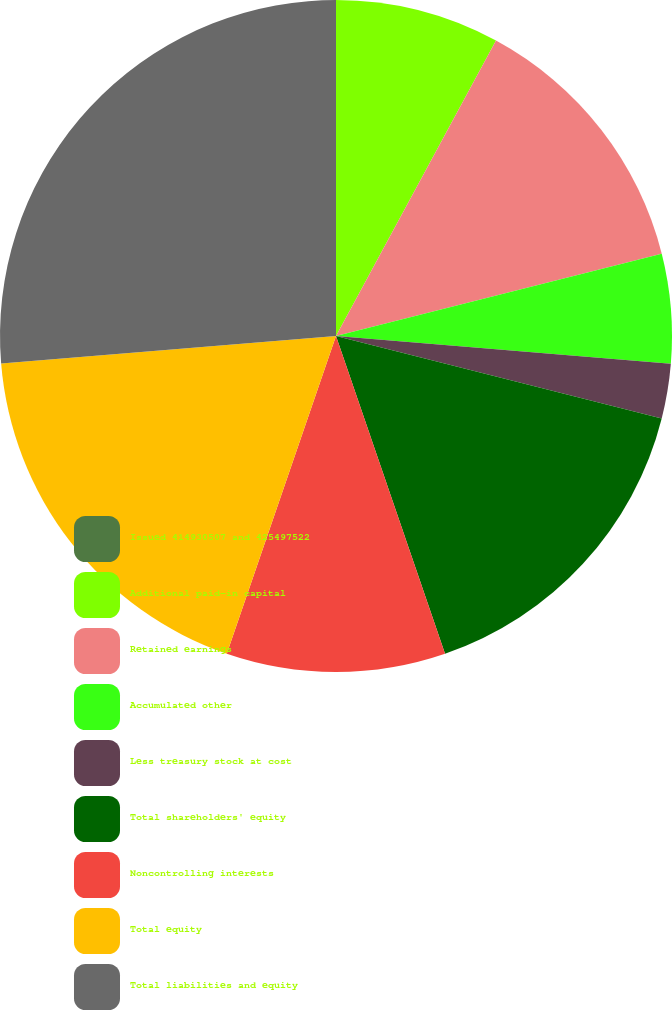Convert chart to OTSL. <chart><loc_0><loc_0><loc_500><loc_500><pie_chart><fcel>Issued 414930507 and 425497522<fcel>Additional paid-in capital<fcel>Retained earnings<fcel>Accumulated other<fcel>Less treasury stock at cost<fcel>Total shareholders' equity<fcel>Noncontrolling interests<fcel>Total equity<fcel>Total liabilities and equity<nl><fcel>0.0%<fcel>7.9%<fcel>13.16%<fcel>5.26%<fcel>2.63%<fcel>15.79%<fcel>10.53%<fcel>18.42%<fcel>26.31%<nl></chart> 